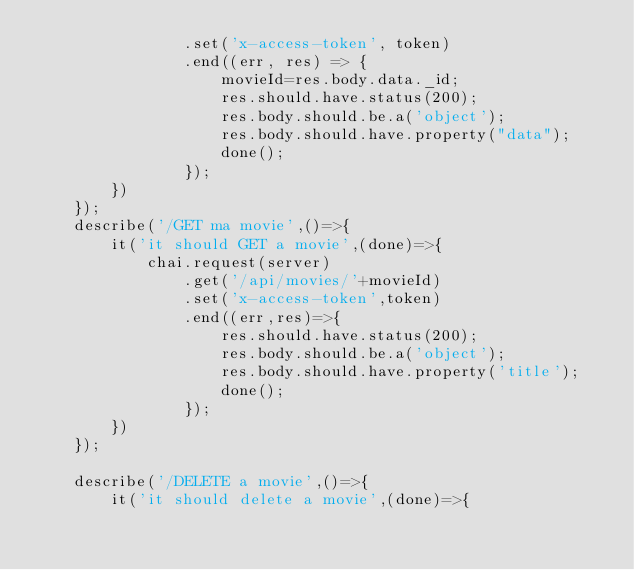Convert code to text. <code><loc_0><loc_0><loc_500><loc_500><_JavaScript_>                .set('x-access-token', token)
                .end((err, res) => {
                    movieId=res.body.data._id;
                    res.should.have.status(200);
                    res.body.should.be.a('object');
                    res.body.should.have.property("data");
                    done();
                });
        })
    });
    describe('/GET ma movie',()=>{
        it('it should GET a movie',(done)=>{
            chai.request(server)
                .get('/api/movies/'+movieId)
                .set('x-access-token',token)
                .end((err,res)=>{
                    res.should.have.status(200);
                    res.body.should.be.a('object');
                    res.body.should.have.property('title');
                    done();
                });
        })
    });

    describe('/DELETE a movie',()=>{
        it('it should delete a movie',(done)=>{</code> 